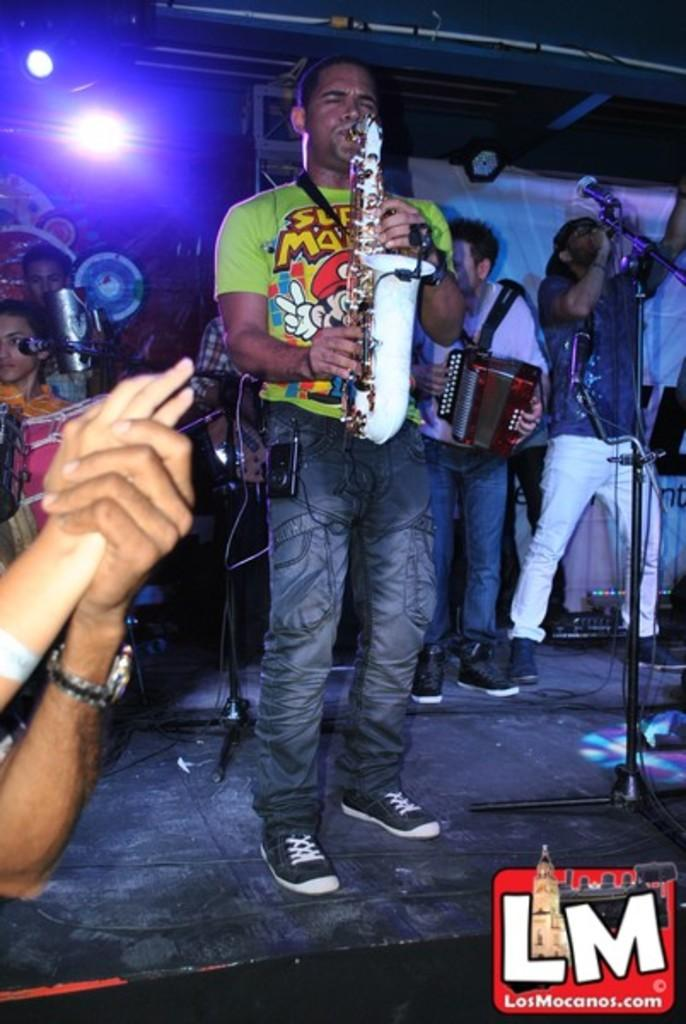What type of objects can be seen in the image? There are musical instruments, microphones, stands, lights, a watch, and a banner in the image. What might be used for amplifying sound in the image? Microphones (mics) can be seen in the image for amplifying sound. What type of structure is present in the image? There are stands in the image, which might be used to hold equipment or provide support. What type of lighting is visible in the image? There are lights in the image, which might be used for illumination or creating a specific atmosphere. What is the group of people doing in the image? There is a group of people standing on stage in the image, which suggests they might be performing or giving a presentation. Can you see a squirrel climbing the volcano in the image? There is no squirrel or volcano present in the image. What type of school is depicted in the image? The image does not show a school; it features a group of people standing on stage with musical instruments, microphones, stands, lights, a watch, and a banner. 